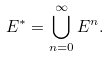<formula> <loc_0><loc_0><loc_500><loc_500>E ^ { * } = \bigcup _ { n = 0 } ^ { \infty } E ^ { n } .</formula> 